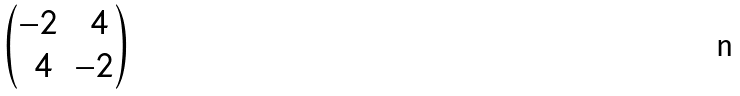<formula> <loc_0><loc_0><loc_500><loc_500>\begin{pmatrix} - 2 & \ 4 \\ \ 4 & - 2 \end{pmatrix}</formula> 